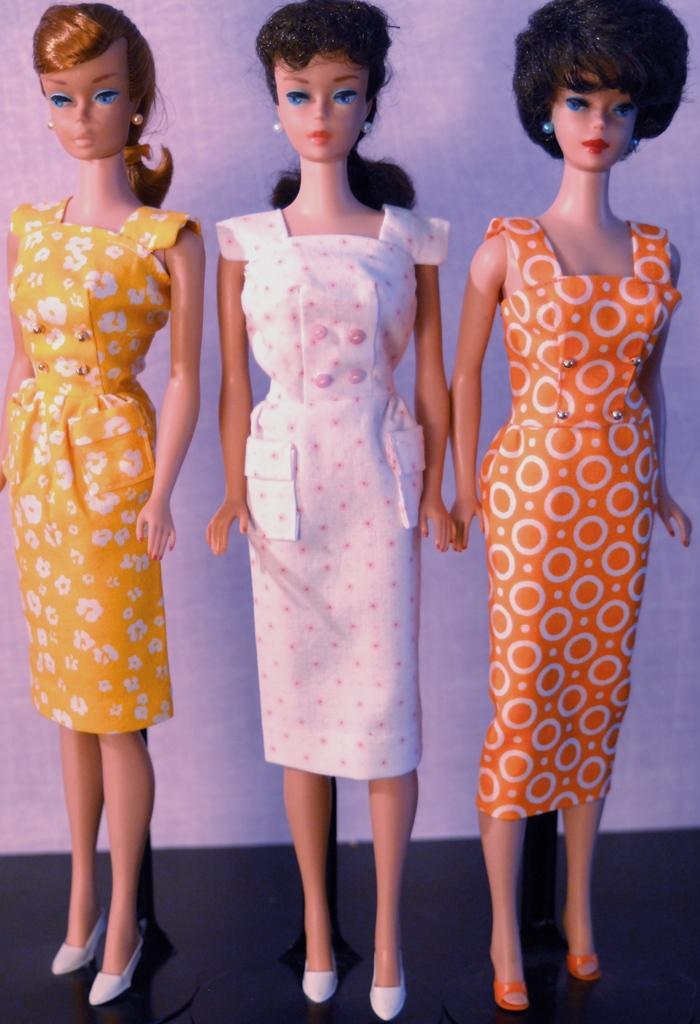Could you give a brief overview of what you see in this image? In this picture there is a doll who is wearing white dress and shoes. On the right there is another who is wearing orange dress. On the left we can see doll who is wearing yellow dress. Back of them we can see a wall. On the bottom there is a table. 